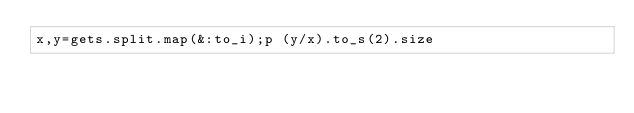Convert code to text. <code><loc_0><loc_0><loc_500><loc_500><_Ruby_>x,y=gets.split.map(&:to_i);p (y/x).to_s(2).size
</code> 